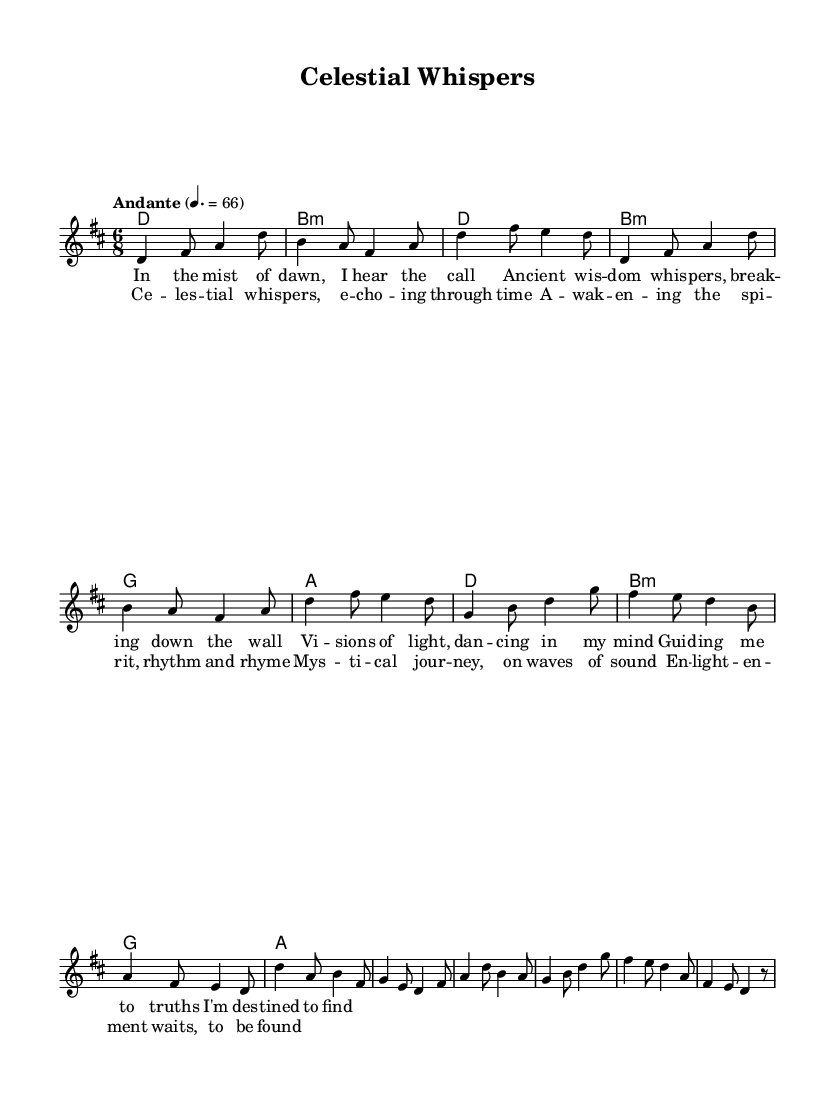What is the key signature of this music? The key signature is indicated by the key signature symbol at the beginning of the staff, which shows two sharps (F# and C#). This indicates the piece is in D major.
Answer: D major What is the time signature of this piece? The time signature is shown at the beginning of the sheet music; it is represented by the two numbers stacked with a '6' on top of a '8', indicating that each measure contains six eighth notes.
Answer: 6/8 What is the tempo marking of the piece? The tempo marking is located above the staff and shows the word "Andante" followed by a metronome marking of 4 equals 66, suggesting a moderately slow pace.
Answer: Andante How many lines are in the chorus section? By counting the lines of lyrics in the chorus section as indicated in the sheet music, there are four lines of lyrics specifically labeled as the chorus.
Answer: Four What is the first note of the melody? The first note of the melody in the sheet music is shown after the global settings and known as the intro. It is a D note in the octave above middle C.
Answer: D Which chord follows the D major chord in the verse? In the verse section, after identifying the chord progression, the chord that follows the D major chord is B minor, as noted in the harmonies placed below the melody.
Answer: B minor How many measures are in the chorus? By counting the sections in the chorus part of the music, there are a total of six measures noted in that section.
Answer: Six 